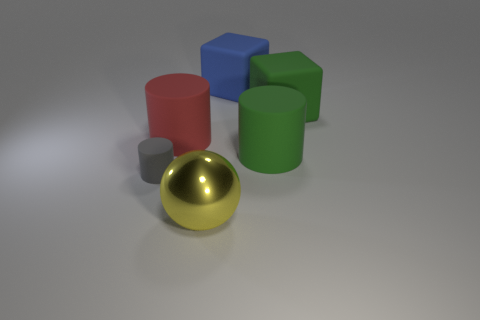Add 1 gray matte things. How many objects exist? 7 Subtract all balls. How many objects are left? 5 Subtract 0 yellow cylinders. How many objects are left? 6 Subtract all large green matte cylinders. Subtract all large yellow spheres. How many objects are left? 4 Add 4 cylinders. How many cylinders are left? 7 Add 2 big yellow balls. How many big yellow balls exist? 3 